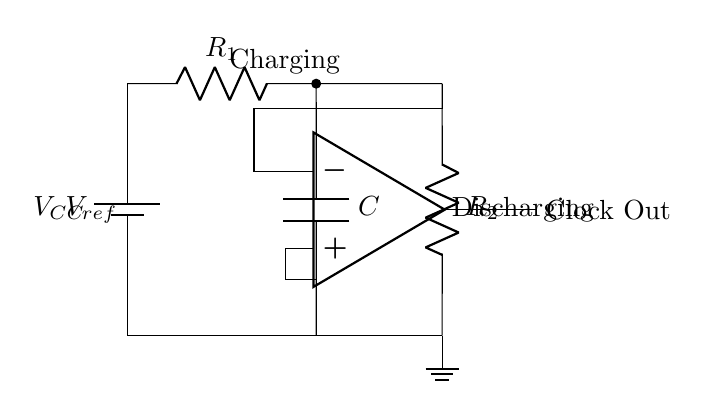What is the reference voltage used in the circuit? The reference voltage is denoted as V_ref, which is connected to the inverting input of the op-amp.
Answer: V_ref What are the values of the resistors in this circuit? The diagram specifies two resistors: R_1 and R_2, but does not provide numerical values, only labels for identification.
Answer: R_1 and R_2 What is the function of the capacitor in this circuit? The capacitor (labeled C) is used to store charge and is pivotal in determining the oscillation frequency of the relaxation oscillator.
Answer: Charge storage Which component generates the clock output signal? The clock output signal is generated from the output of the operational amplifier (op-amp) in the circuit.
Answer: Op-amp Explain the purpose of the comparator in this circuit. The comparator, represented by the op-amp, compares the voltage across the capacitor with the reference voltage. When the capacitor voltage exceeds V_ref, the op-amp output toggles, initiating charging and discharging processes that create the clock signal.
Answer: To compare voltages What happens when the voltage across the capacitor exceeds the reference voltage? When the capacitor voltage exceeds V_ref, the output of the op-amp will switch states, leading to a change in the charging/discharging cycle of the capacitor which generates the clock signal.
Answer: The output switches What indicates the charging process in the diagram? The charging process is indicated at the top of the circuit diagram with a label noting 'Charging,' showing that the capacitor is being charged via one of the resistors.
Answer: Charging 